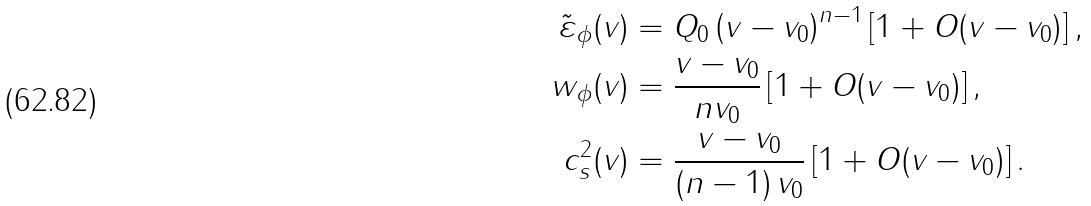Convert formula to latex. <formula><loc_0><loc_0><loc_500><loc_500>\tilde { \varepsilon } _ { \phi } ( v ) & = Q _ { 0 } \left ( v - v _ { 0 } \right ) ^ { n - 1 } \left [ 1 + O ( v - v _ { 0 } ) \right ] , \\ w _ { \phi } ( v ) & = \frac { v - v _ { 0 } } { n v _ { 0 } } \left [ 1 + O ( v - v _ { 0 } ) \right ] , \\ c _ { s } ^ { 2 } ( v ) & = \frac { v - v _ { 0 } } { \left ( n - 1 \right ) v _ { 0 } } \left [ 1 + O ( v - v _ { 0 } ) \right ] .</formula> 